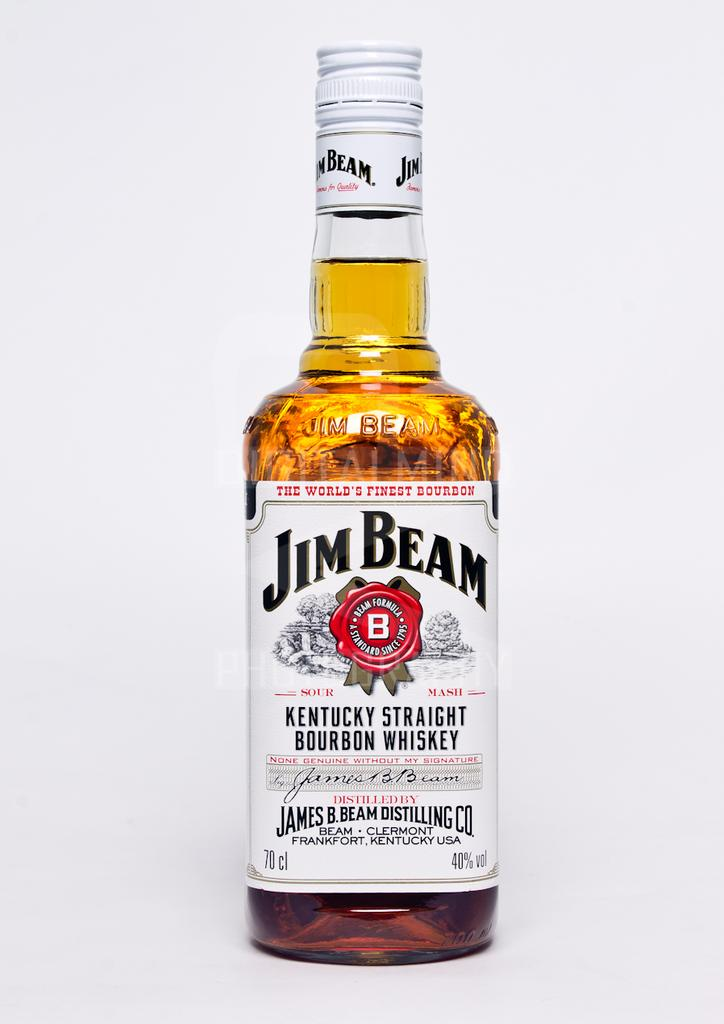What is in the bottle that is visible in the image? There is a wine bottle in the image. What is inside the wine bottle? The wine bottle contains wine. Is there any labeling on the wine bottle? Yes, there is a white sticker on the wine bottle. What does the sticker say? The sticker is labeled "JIM BEAM." What color is the wine bottle cap? The wine bottle cap is white in color. What time of day is it in the image, according to the belief of the person holding the wine bottle? The image does not provide any information about the time of day or the beliefs of the person holding the wine bottle. 